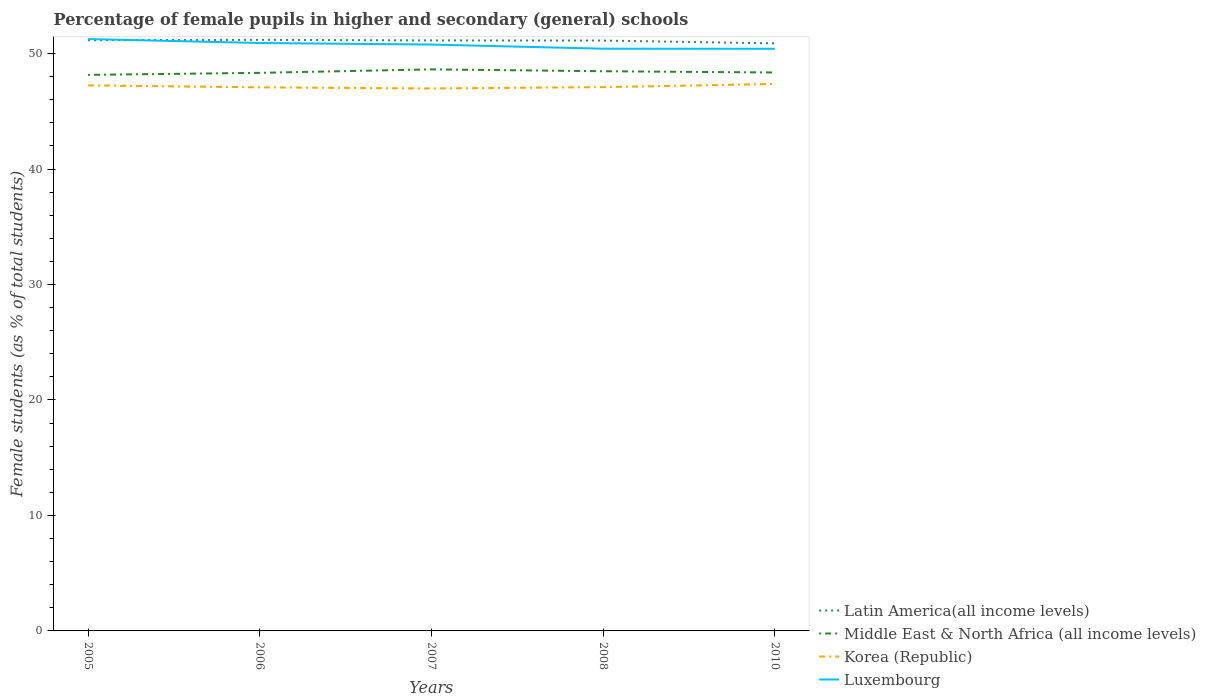How many different coloured lines are there?
Offer a very short reply. 4. Does the line corresponding to Korea (Republic) intersect with the line corresponding to Middle East & North Africa (all income levels)?
Your answer should be compact. No. Across all years, what is the maximum percentage of female pupils in higher and secondary schools in Korea (Republic)?
Your answer should be compact. 46.97. In which year was the percentage of female pupils in higher and secondary schools in Latin America(all income levels) maximum?
Provide a succinct answer. 2010. What is the total percentage of female pupils in higher and secondary schools in Luxembourg in the graph?
Your response must be concise. 0.84. What is the difference between the highest and the second highest percentage of female pupils in higher and secondary schools in Luxembourg?
Your answer should be compact. 0.84. Is the percentage of female pupils in higher and secondary schools in Middle East & North Africa (all income levels) strictly greater than the percentage of female pupils in higher and secondary schools in Korea (Republic) over the years?
Provide a succinct answer. No. How many lines are there?
Give a very brief answer. 4. How many years are there in the graph?
Keep it short and to the point. 5. What is the difference between two consecutive major ticks on the Y-axis?
Make the answer very short. 10. Where does the legend appear in the graph?
Provide a short and direct response. Bottom right. How many legend labels are there?
Provide a succinct answer. 4. What is the title of the graph?
Your answer should be compact. Percentage of female pupils in higher and secondary (general) schools. Does "Burkina Faso" appear as one of the legend labels in the graph?
Give a very brief answer. No. What is the label or title of the Y-axis?
Keep it short and to the point. Female students (as % of total students). What is the Female students (as % of total students) of Latin America(all income levels) in 2005?
Give a very brief answer. 51.16. What is the Female students (as % of total students) in Middle East & North Africa (all income levels) in 2005?
Make the answer very short. 48.15. What is the Female students (as % of total students) in Korea (Republic) in 2005?
Ensure brevity in your answer.  47.24. What is the Female students (as % of total students) of Luxembourg in 2005?
Provide a short and direct response. 51.25. What is the Female students (as % of total students) in Latin America(all income levels) in 2006?
Your response must be concise. 51.19. What is the Female students (as % of total students) in Middle East & North Africa (all income levels) in 2006?
Your response must be concise. 48.33. What is the Female students (as % of total students) in Korea (Republic) in 2006?
Provide a short and direct response. 47.07. What is the Female students (as % of total students) of Luxembourg in 2006?
Your response must be concise. 50.91. What is the Female students (as % of total students) of Latin America(all income levels) in 2007?
Provide a succinct answer. 51.13. What is the Female students (as % of total students) of Middle East & North Africa (all income levels) in 2007?
Make the answer very short. 48.63. What is the Female students (as % of total students) in Korea (Republic) in 2007?
Offer a terse response. 46.97. What is the Female students (as % of total students) in Luxembourg in 2007?
Keep it short and to the point. 50.78. What is the Female students (as % of total students) of Latin America(all income levels) in 2008?
Your response must be concise. 51.12. What is the Female students (as % of total students) in Middle East & North Africa (all income levels) in 2008?
Your answer should be very brief. 48.47. What is the Female students (as % of total students) in Korea (Republic) in 2008?
Ensure brevity in your answer.  47.09. What is the Female students (as % of total students) of Luxembourg in 2008?
Offer a terse response. 50.42. What is the Female students (as % of total students) of Latin America(all income levels) in 2010?
Ensure brevity in your answer.  50.88. What is the Female students (as % of total students) of Middle East & North Africa (all income levels) in 2010?
Ensure brevity in your answer.  48.36. What is the Female students (as % of total students) of Korea (Republic) in 2010?
Provide a succinct answer. 47.36. What is the Female students (as % of total students) of Luxembourg in 2010?
Offer a terse response. 50.41. Across all years, what is the maximum Female students (as % of total students) of Latin America(all income levels)?
Provide a short and direct response. 51.19. Across all years, what is the maximum Female students (as % of total students) of Middle East & North Africa (all income levels)?
Your response must be concise. 48.63. Across all years, what is the maximum Female students (as % of total students) in Korea (Republic)?
Provide a short and direct response. 47.36. Across all years, what is the maximum Female students (as % of total students) in Luxembourg?
Your response must be concise. 51.25. Across all years, what is the minimum Female students (as % of total students) of Latin America(all income levels)?
Your answer should be compact. 50.88. Across all years, what is the minimum Female students (as % of total students) in Middle East & North Africa (all income levels)?
Your answer should be very brief. 48.15. Across all years, what is the minimum Female students (as % of total students) in Korea (Republic)?
Offer a very short reply. 46.97. Across all years, what is the minimum Female students (as % of total students) of Luxembourg?
Your answer should be compact. 50.41. What is the total Female students (as % of total students) in Latin America(all income levels) in the graph?
Offer a terse response. 255.48. What is the total Female students (as % of total students) in Middle East & North Africa (all income levels) in the graph?
Offer a very short reply. 241.93. What is the total Female students (as % of total students) of Korea (Republic) in the graph?
Your answer should be very brief. 235.74. What is the total Female students (as % of total students) in Luxembourg in the graph?
Your answer should be very brief. 253.77. What is the difference between the Female students (as % of total students) of Latin America(all income levels) in 2005 and that in 2006?
Keep it short and to the point. -0.03. What is the difference between the Female students (as % of total students) in Middle East & North Africa (all income levels) in 2005 and that in 2006?
Your response must be concise. -0.18. What is the difference between the Female students (as % of total students) in Korea (Republic) in 2005 and that in 2006?
Offer a terse response. 0.17. What is the difference between the Female students (as % of total students) in Luxembourg in 2005 and that in 2006?
Offer a terse response. 0.34. What is the difference between the Female students (as % of total students) in Latin America(all income levels) in 2005 and that in 2007?
Keep it short and to the point. 0.02. What is the difference between the Female students (as % of total students) in Middle East & North Africa (all income levels) in 2005 and that in 2007?
Make the answer very short. -0.48. What is the difference between the Female students (as % of total students) of Korea (Republic) in 2005 and that in 2007?
Give a very brief answer. 0.27. What is the difference between the Female students (as % of total students) in Luxembourg in 2005 and that in 2007?
Your answer should be very brief. 0.48. What is the difference between the Female students (as % of total students) of Latin America(all income levels) in 2005 and that in 2008?
Make the answer very short. 0.03. What is the difference between the Female students (as % of total students) of Middle East & North Africa (all income levels) in 2005 and that in 2008?
Your answer should be very brief. -0.32. What is the difference between the Female students (as % of total students) in Korea (Republic) in 2005 and that in 2008?
Provide a short and direct response. 0.15. What is the difference between the Female students (as % of total students) in Luxembourg in 2005 and that in 2008?
Offer a terse response. 0.84. What is the difference between the Female students (as % of total students) in Latin America(all income levels) in 2005 and that in 2010?
Give a very brief answer. 0.28. What is the difference between the Female students (as % of total students) in Middle East & North Africa (all income levels) in 2005 and that in 2010?
Make the answer very short. -0.21. What is the difference between the Female students (as % of total students) in Korea (Republic) in 2005 and that in 2010?
Make the answer very short. -0.12. What is the difference between the Female students (as % of total students) of Luxembourg in 2005 and that in 2010?
Your response must be concise. 0.84. What is the difference between the Female students (as % of total students) of Latin America(all income levels) in 2006 and that in 2007?
Provide a short and direct response. 0.05. What is the difference between the Female students (as % of total students) of Middle East & North Africa (all income levels) in 2006 and that in 2007?
Provide a short and direct response. -0.3. What is the difference between the Female students (as % of total students) in Korea (Republic) in 2006 and that in 2007?
Provide a succinct answer. 0.1. What is the difference between the Female students (as % of total students) of Luxembourg in 2006 and that in 2007?
Offer a very short reply. 0.13. What is the difference between the Female students (as % of total students) in Latin America(all income levels) in 2006 and that in 2008?
Ensure brevity in your answer.  0.06. What is the difference between the Female students (as % of total students) in Middle East & North Africa (all income levels) in 2006 and that in 2008?
Your answer should be compact. -0.14. What is the difference between the Female students (as % of total students) of Korea (Republic) in 2006 and that in 2008?
Provide a succinct answer. -0.02. What is the difference between the Female students (as % of total students) of Luxembourg in 2006 and that in 2008?
Provide a succinct answer. 0.49. What is the difference between the Female students (as % of total students) in Latin America(all income levels) in 2006 and that in 2010?
Make the answer very short. 0.31. What is the difference between the Female students (as % of total students) in Middle East & North Africa (all income levels) in 2006 and that in 2010?
Provide a short and direct response. -0.03. What is the difference between the Female students (as % of total students) in Korea (Republic) in 2006 and that in 2010?
Provide a short and direct response. -0.29. What is the difference between the Female students (as % of total students) in Luxembourg in 2006 and that in 2010?
Offer a very short reply. 0.5. What is the difference between the Female students (as % of total students) in Latin America(all income levels) in 2007 and that in 2008?
Keep it short and to the point. 0.01. What is the difference between the Female students (as % of total students) in Middle East & North Africa (all income levels) in 2007 and that in 2008?
Ensure brevity in your answer.  0.16. What is the difference between the Female students (as % of total students) of Korea (Republic) in 2007 and that in 2008?
Provide a short and direct response. -0.11. What is the difference between the Female students (as % of total students) of Luxembourg in 2007 and that in 2008?
Your answer should be very brief. 0.36. What is the difference between the Female students (as % of total students) of Latin America(all income levels) in 2007 and that in 2010?
Provide a succinct answer. 0.26. What is the difference between the Female students (as % of total students) of Middle East & North Africa (all income levels) in 2007 and that in 2010?
Offer a very short reply. 0.27. What is the difference between the Female students (as % of total students) of Korea (Republic) in 2007 and that in 2010?
Your answer should be very brief. -0.39. What is the difference between the Female students (as % of total students) in Luxembourg in 2007 and that in 2010?
Give a very brief answer. 0.37. What is the difference between the Female students (as % of total students) in Latin America(all income levels) in 2008 and that in 2010?
Keep it short and to the point. 0.24. What is the difference between the Female students (as % of total students) of Middle East & North Africa (all income levels) in 2008 and that in 2010?
Your answer should be compact. 0.11. What is the difference between the Female students (as % of total students) in Korea (Republic) in 2008 and that in 2010?
Provide a succinct answer. -0.27. What is the difference between the Female students (as % of total students) in Luxembourg in 2008 and that in 2010?
Your response must be concise. 0.01. What is the difference between the Female students (as % of total students) in Latin America(all income levels) in 2005 and the Female students (as % of total students) in Middle East & North Africa (all income levels) in 2006?
Provide a succinct answer. 2.83. What is the difference between the Female students (as % of total students) in Latin America(all income levels) in 2005 and the Female students (as % of total students) in Korea (Republic) in 2006?
Offer a very short reply. 4.09. What is the difference between the Female students (as % of total students) in Latin America(all income levels) in 2005 and the Female students (as % of total students) in Luxembourg in 2006?
Your answer should be compact. 0.24. What is the difference between the Female students (as % of total students) in Middle East & North Africa (all income levels) in 2005 and the Female students (as % of total students) in Korea (Republic) in 2006?
Your answer should be very brief. 1.08. What is the difference between the Female students (as % of total students) of Middle East & North Africa (all income levels) in 2005 and the Female students (as % of total students) of Luxembourg in 2006?
Provide a succinct answer. -2.76. What is the difference between the Female students (as % of total students) in Korea (Republic) in 2005 and the Female students (as % of total students) in Luxembourg in 2006?
Your answer should be compact. -3.67. What is the difference between the Female students (as % of total students) in Latin America(all income levels) in 2005 and the Female students (as % of total students) in Middle East & North Africa (all income levels) in 2007?
Keep it short and to the point. 2.53. What is the difference between the Female students (as % of total students) in Latin America(all income levels) in 2005 and the Female students (as % of total students) in Korea (Republic) in 2007?
Your answer should be very brief. 4.18. What is the difference between the Female students (as % of total students) of Latin America(all income levels) in 2005 and the Female students (as % of total students) of Luxembourg in 2007?
Your answer should be compact. 0.38. What is the difference between the Female students (as % of total students) of Middle East & North Africa (all income levels) in 2005 and the Female students (as % of total students) of Korea (Republic) in 2007?
Provide a succinct answer. 1.18. What is the difference between the Female students (as % of total students) in Middle East & North Africa (all income levels) in 2005 and the Female students (as % of total students) in Luxembourg in 2007?
Provide a succinct answer. -2.63. What is the difference between the Female students (as % of total students) of Korea (Republic) in 2005 and the Female students (as % of total students) of Luxembourg in 2007?
Your answer should be very brief. -3.53. What is the difference between the Female students (as % of total students) in Latin America(all income levels) in 2005 and the Female students (as % of total students) in Middle East & North Africa (all income levels) in 2008?
Ensure brevity in your answer.  2.69. What is the difference between the Female students (as % of total students) of Latin America(all income levels) in 2005 and the Female students (as % of total students) of Korea (Republic) in 2008?
Your answer should be compact. 4.07. What is the difference between the Female students (as % of total students) of Latin America(all income levels) in 2005 and the Female students (as % of total students) of Luxembourg in 2008?
Provide a short and direct response. 0.74. What is the difference between the Female students (as % of total students) in Middle East & North Africa (all income levels) in 2005 and the Female students (as % of total students) in Korea (Republic) in 2008?
Your answer should be very brief. 1.06. What is the difference between the Female students (as % of total students) in Middle East & North Africa (all income levels) in 2005 and the Female students (as % of total students) in Luxembourg in 2008?
Ensure brevity in your answer.  -2.27. What is the difference between the Female students (as % of total students) in Korea (Republic) in 2005 and the Female students (as % of total students) in Luxembourg in 2008?
Make the answer very short. -3.17. What is the difference between the Female students (as % of total students) in Latin America(all income levels) in 2005 and the Female students (as % of total students) in Middle East & North Africa (all income levels) in 2010?
Ensure brevity in your answer.  2.8. What is the difference between the Female students (as % of total students) of Latin America(all income levels) in 2005 and the Female students (as % of total students) of Korea (Republic) in 2010?
Your response must be concise. 3.79. What is the difference between the Female students (as % of total students) in Latin America(all income levels) in 2005 and the Female students (as % of total students) in Luxembourg in 2010?
Offer a very short reply. 0.75. What is the difference between the Female students (as % of total students) of Middle East & North Africa (all income levels) in 2005 and the Female students (as % of total students) of Korea (Republic) in 2010?
Keep it short and to the point. 0.79. What is the difference between the Female students (as % of total students) in Middle East & North Africa (all income levels) in 2005 and the Female students (as % of total students) in Luxembourg in 2010?
Ensure brevity in your answer.  -2.26. What is the difference between the Female students (as % of total students) of Korea (Republic) in 2005 and the Female students (as % of total students) of Luxembourg in 2010?
Your answer should be compact. -3.17. What is the difference between the Female students (as % of total students) of Latin America(all income levels) in 2006 and the Female students (as % of total students) of Middle East & North Africa (all income levels) in 2007?
Offer a terse response. 2.56. What is the difference between the Female students (as % of total students) of Latin America(all income levels) in 2006 and the Female students (as % of total students) of Korea (Republic) in 2007?
Provide a short and direct response. 4.21. What is the difference between the Female students (as % of total students) in Latin America(all income levels) in 2006 and the Female students (as % of total students) in Luxembourg in 2007?
Provide a short and direct response. 0.41. What is the difference between the Female students (as % of total students) of Middle East & North Africa (all income levels) in 2006 and the Female students (as % of total students) of Korea (Republic) in 2007?
Your answer should be very brief. 1.35. What is the difference between the Female students (as % of total students) in Middle East & North Africa (all income levels) in 2006 and the Female students (as % of total students) in Luxembourg in 2007?
Keep it short and to the point. -2.45. What is the difference between the Female students (as % of total students) of Korea (Republic) in 2006 and the Female students (as % of total students) of Luxembourg in 2007?
Make the answer very short. -3.71. What is the difference between the Female students (as % of total students) of Latin America(all income levels) in 2006 and the Female students (as % of total students) of Middle East & North Africa (all income levels) in 2008?
Your answer should be compact. 2.72. What is the difference between the Female students (as % of total students) of Latin America(all income levels) in 2006 and the Female students (as % of total students) of Korea (Republic) in 2008?
Ensure brevity in your answer.  4.1. What is the difference between the Female students (as % of total students) of Latin America(all income levels) in 2006 and the Female students (as % of total students) of Luxembourg in 2008?
Give a very brief answer. 0.77. What is the difference between the Female students (as % of total students) in Middle East & North Africa (all income levels) in 2006 and the Female students (as % of total students) in Korea (Republic) in 2008?
Give a very brief answer. 1.24. What is the difference between the Female students (as % of total students) in Middle East & North Africa (all income levels) in 2006 and the Female students (as % of total students) in Luxembourg in 2008?
Give a very brief answer. -2.09. What is the difference between the Female students (as % of total students) of Korea (Republic) in 2006 and the Female students (as % of total students) of Luxembourg in 2008?
Your answer should be compact. -3.35. What is the difference between the Female students (as % of total students) of Latin America(all income levels) in 2006 and the Female students (as % of total students) of Middle East & North Africa (all income levels) in 2010?
Offer a very short reply. 2.83. What is the difference between the Female students (as % of total students) in Latin America(all income levels) in 2006 and the Female students (as % of total students) in Korea (Republic) in 2010?
Give a very brief answer. 3.82. What is the difference between the Female students (as % of total students) of Latin America(all income levels) in 2006 and the Female students (as % of total students) of Luxembourg in 2010?
Your response must be concise. 0.78. What is the difference between the Female students (as % of total students) in Middle East & North Africa (all income levels) in 2006 and the Female students (as % of total students) in Korea (Republic) in 2010?
Your answer should be very brief. 0.96. What is the difference between the Female students (as % of total students) of Middle East & North Africa (all income levels) in 2006 and the Female students (as % of total students) of Luxembourg in 2010?
Ensure brevity in your answer.  -2.08. What is the difference between the Female students (as % of total students) in Korea (Republic) in 2006 and the Female students (as % of total students) in Luxembourg in 2010?
Make the answer very short. -3.34. What is the difference between the Female students (as % of total students) in Latin America(all income levels) in 2007 and the Female students (as % of total students) in Middle East & North Africa (all income levels) in 2008?
Your answer should be very brief. 2.67. What is the difference between the Female students (as % of total students) in Latin America(all income levels) in 2007 and the Female students (as % of total students) in Korea (Republic) in 2008?
Ensure brevity in your answer.  4.05. What is the difference between the Female students (as % of total students) in Latin America(all income levels) in 2007 and the Female students (as % of total students) in Luxembourg in 2008?
Make the answer very short. 0.72. What is the difference between the Female students (as % of total students) in Middle East & North Africa (all income levels) in 2007 and the Female students (as % of total students) in Korea (Republic) in 2008?
Your answer should be very brief. 1.54. What is the difference between the Female students (as % of total students) in Middle East & North Africa (all income levels) in 2007 and the Female students (as % of total students) in Luxembourg in 2008?
Provide a short and direct response. -1.79. What is the difference between the Female students (as % of total students) in Korea (Republic) in 2007 and the Female students (as % of total students) in Luxembourg in 2008?
Provide a succinct answer. -3.44. What is the difference between the Female students (as % of total students) of Latin America(all income levels) in 2007 and the Female students (as % of total students) of Middle East & North Africa (all income levels) in 2010?
Give a very brief answer. 2.78. What is the difference between the Female students (as % of total students) of Latin America(all income levels) in 2007 and the Female students (as % of total students) of Korea (Republic) in 2010?
Your answer should be compact. 3.77. What is the difference between the Female students (as % of total students) in Latin America(all income levels) in 2007 and the Female students (as % of total students) in Luxembourg in 2010?
Give a very brief answer. 0.72. What is the difference between the Female students (as % of total students) of Middle East & North Africa (all income levels) in 2007 and the Female students (as % of total students) of Korea (Republic) in 2010?
Give a very brief answer. 1.26. What is the difference between the Female students (as % of total students) in Middle East & North Africa (all income levels) in 2007 and the Female students (as % of total students) in Luxembourg in 2010?
Your answer should be very brief. -1.78. What is the difference between the Female students (as % of total students) of Korea (Republic) in 2007 and the Female students (as % of total students) of Luxembourg in 2010?
Provide a short and direct response. -3.43. What is the difference between the Female students (as % of total students) in Latin America(all income levels) in 2008 and the Female students (as % of total students) in Middle East & North Africa (all income levels) in 2010?
Ensure brevity in your answer.  2.77. What is the difference between the Female students (as % of total students) in Latin America(all income levels) in 2008 and the Female students (as % of total students) in Korea (Republic) in 2010?
Offer a very short reply. 3.76. What is the difference between the Female students (as % of total students) of Latin America(all income levels) in 2008 and the Female students (as % of total students) of Luxembourg in 2010?
Keep it short and to the point. 0.71. What is the difference between the Female students (as % of total students) of Middle East & North Africa (all income levels) in 2008 and the Female students (as % of total students) of Korea (Republic) in 2010?
Your answer should be very brief. 1.1. What is the difference between the Female students (as % of total students) in Middle East & North Africa (all income levels) in 2008 and the Female students (as % of total students) in Luxembourg in 2010?
Your answer should be compact. -1.94. What is the difference between the Female students (as % of total students) in Korea (Republic) in 2008 and the Female students (as % of total students) in Luxembourg in 2010?
Offer a terse response. -3.32. What is the average Female students (as % of total students) in Latin America(all income levels) per year?
Your response must be concise. 51.1. What is the average Female students (as % of total students) of Middle East & North Africa (all income levels) per year?
Make the answer very short. 48.39. What is the average Female students (as % of total students) in Korea (Republic) per year?
Your answer should be very brief. 47.15. What is the average Female students (as % of total students) of Luxembourg per year?
Your response must be concise. 50.75. In the year 2005, what is the difference between the Female students (as % of total students) of Latin America(all income levels) and Female students (as % of total students) of Middle East & North Africa (all income levels)?
Ensure brevity in your answer.  3. In the year 2005, what is the difference between the Female students (as % of total students) in Latin America(all income levels) and Female students (as % of total students) in Korea (Republic)?
Offer a terse response. 3.91. In the year 2005, what is the difference between the Female students (as % of total students) in Latin America(all income levels) and Female students (as % of total students) in Luxembourg?
Provide a succinct answer. -0.1. In the year 2005, what is the difference between the Female students (as % of total students) in Middle East & North Africa (all income levels) and Female students (as % of total students) in Korea (Republic)?
Provide a succinct answer. 0.91. In the year 2005, what is the difference between the Female students (as % of total students) of Middle East & North Africa (all income levels) and Female students (as % of total students) of Luxembourg?
Provide a short and direct response. -3.1. In the year 2005, what is the difference between the Female students (as % of total students) of Korea (Republic) and Female students (as % of total students) of Luxembourg?
Offer a terse response. -4.01. In the year 2006, what is the difference between the Female students (as % of total students) in Latin America(all income levels) and Female students (as % of total students) in Middle East & North Africa (all income levels)?
Your answer should be compact. 2.86. In the year 2006, what is the difference between the Female students (as % of total students) in Latin America(all income levels) and Female students (as % of total students) in Korea (Republic)?
Your answer should be compact. 4.12. In the year 2006, what is the difference between the Female students (as % of total students) of Latin America(all income levels) and Female students (as % of total students) of Luxembourg?
Make the answer very short. 0.27. In the year 2006, what is the difference between the Female students (as % of total students) of Middle East & North Africa (all income levels) and Female students (as % of total students) of Korea (Republic)?
Provide a succinct answer. 1.26. In the year 2006, what is the difference between the Female students (as % of total students) in Middle East & North Africa (all income levels) and Female students (as % of total students) in Luxembourg?
Provide a succinct answer. -2.58. In the year 2006, what is the difference between the Female students (as % of total students) of Korea (Republic) and Female students (as % of total students) of Luxembourg?
Ensure brevity in your answer.  -3.84. In the year 2007, what is the difference between the Female students (as % of total students) of Latin America(all income levels) and Female students (as % of total students) of Middle East & North Africa (all income levels)?
Keep it short and to the point. 2.51. In the year 2007, what is the difference between the Female students (as % of total students) of Latin America(all income levels) and Female students (as % of total students) of Korea (Republic)?
Your answer should be compact. 4.16. In the year 2007, what is the difference between the Female students (as % of total students) in Latin America(all income levels) and Female students (as % of total students) in Luxembourg?
Offer a very short reply. 0.36. In the year 2007, what is the difference between the Female students (as % of total students) in Middle East & North Africa (all income levels) and Female students (as % of total students) in Korea (Republic)?
Keep it short and to the point. 1.65. In the year 2007, what is the difference between the Female students (as % of total students) in Middle East & North Africa (all income levels) and Female students (as % of total students) in Luxembourg?
Give a very brief answer. -2.15. In the year 2007, what is the difference between the Female students (as % of total students) in Korea (Republic) and Female students (as % of total students) in Luxembourg?
Your answer should be very brief. -3.8. In the year 2008, what is the difference between the Female students (as % of total students) in Latin America(all income levels) and Female students (as % of total students) in Middle East & North Africa (all income levels)?
Your response must be concise. 2.66. In the year 2008, what is the difference between the Female students (as % of total students) of Latin America(all income levels) and Female students (as % of total students) of Korea (Republic)?
Make the answer very short. 4.03. In the year 2008, what is the difference between the Female students (as % of total students) of Latin America(all income levels) and Female students (as % of total students) of Luxembourg?
Your answer should be very brief. 0.7. In the year 2008, what is the difference between the Female students (as % of total students) in Middle East & North Africa (all income levels) and Female students (as % of total students) in Korea (Republic)?
Make the answer very short. 1.38. In the year 2008, what is the difference between the Female students (as % of total students) of Middle East & North Africa (all income levels) and Female students (as % of total students) of Luxembourg?
Keep it short and to the point. -1.95. In the year 2008, what is the difference between the Female students (as % of total students) of Korea (Republic) and Female students (as % of total students) of Luxembourg?
Provide a short and direct response. -3.33. In the year 2010, what is the difference between the Female students (as % of total students) of Latin America(all income levels) and Female students (as % of total students) of Middle East & North Africa (all income levels)?
Give a very brief answer. 2.52. In the year 2010, what is the difference between the Female students (as % of total students) in Latin America(all income levels) and Female students (as % of total students) in Korea (Republic)?
Provide a succinct answer. 3.52. In the year 2010, what is the difference between the Female students (as % of total students) of Latin America(all income levels) and Female students (as % of total students) of Luxembourg?
Offer a terse response. 0.47. In the year 2010, what is the difference between the Female students (as % of total students) in Middle East & North Africa (all income levels) and Female students (as % of total students) in Luxembourg?
Offer a very short reply. -2.05. In the year 2010, what is the difference between the Female students (as % of total students) in Korea (Republic) and Female students (as % of total students) in Luxembourg?
Offer a terse response. -3.05. What is the ratio of the Female students (as % of total students) in Latin America(all income levels) in 2005 to that in 2006?
Give a very brief answer. 1. What is the ratio of the Female students (as % of total students) in Korea (Republic) in 2005 to that in 2006?
Provide a short and direct response. 1. What is the ratio of the Female students (as % of total students) of Luxembourg in 2005 to that in 2006?
Your answer should be compact. 1.01. What is the ratio of the Female students (as % of total students) of Middle East & North Africa (all income levels) in 2005 to that in 2007?
Ensure brevity in your answer.  0.99. What is the ratio of the Female students (as % of total students) of Korea (Republic) in 2005 to that in 2007?
Keep it short and to the point. 1.01. What is the ratio of the Female students (as % of total students) in Luxembourg in 2005 to that in 2007?
Your response must be concise. 1.01. What is the ratio of the Female students (as % of total students) of Latin America(all income levels) in 2005 to that in 2008?
Ensure brevity in your answer.  1. What is the ratio of the Female students (as % of total students) in Middle East & North Africa (all income levels) in 2005 to that in 2008?
Provide a short and direct response. 0.99. What is the ratio of the Female students (as % of total students) of Luxembourg in 2005 to that in 2008?
Provide a short and direct response. 1.02. What is the ratio of the Female students (as % of total students) of Latin America(all income levels) in 2005 to that in 2010?
Offer a terse response. 1.01. What is the ratio of the Female students (as % of total students) in Middle East & North Africa (all income levels) in 2005 to that in 2010?
Give a very brief answer. 1. What is the ratio of the Female students (as % of total students) of Luxembourg in 2005 to that in 2010?
Your answer should be compact. 1.02. What is the ratio of the Female students (as % of total students) of Luxembourg in 2006 to that in 2007?
Provide a succinct answer. 1. What is the ratio of the Female students (as % of total students) of Latin America(all income levels) in 2006 to that in 2008?
Your answer should be very brief. 1. What is the ratio of the Female students (as % of total students) in Luxembourg in 2006 to that in 2008?
Your response must be concise. 1.01. What is the ratio of the Female students (as % of total students) of Luxembourg in 2006 to that in 2010?
Give a very brief answer. 1.01. What is the ratio of the Female students (as % of total students) in Korea (Republic) in 2007 to that in 2008?
Ensure brevity in your answer.  1. What is the ratio of the Female students (as % of total students) in Luxembourg in 2007 to that in 2008?
Your answer should be compact. 1.01. What is the ratio of the Female students (as % of total students) of Middle East & North Africa (all income levels) in 2007 to that in 2010?
Offer a terse response. 1.01. What is the ratio of the Female students (as % of total students) in Luxembourg in 2007 to that in 2010?
Offer a very short reply. 1.01. What is the ratio of the Female students (as % of total students) of Middle East & North Africa (all income levels) in 2008 to that in 2010?
Provide a succinct answer. 1. What is the difference between the highest and the second highest Female students (as % of total students) of Latin America(all income levels)?
Your response must be concise. 0.03. What is the difference between the highest and the second highest Female students (as % of total students) in Middle East & North Africa (all income levels)?
Your answer should be compact. 0.16. What is the difference between the highest and the second highest Female students (as % of total students) in Korea (Republic)?
Your response must be concise. 0.12. What is the difference between the highest and the second highest Female students (as % of total students) in Luxembourg?
Give a very brief answer. 0.34. What is the difference between the highest and the lowest Female students (as % of total students) in Latin America(all income levels)?
Provide a short and direct response. 0.31. What is the difference between the highest and the lowest Female students (as % of total students) in Middle East & North Africa (all income levels)?
Your answer should be compact. 0.48. What is the difference between the highest and the lowest Female students (as % of total students) in Korea (Republic)?
Offer a very short reply. 0.39. What is the difference between the highest and the lowest Female students (as % of total students) in Luxembourg?
Provide a succinct answer. 0.84. 